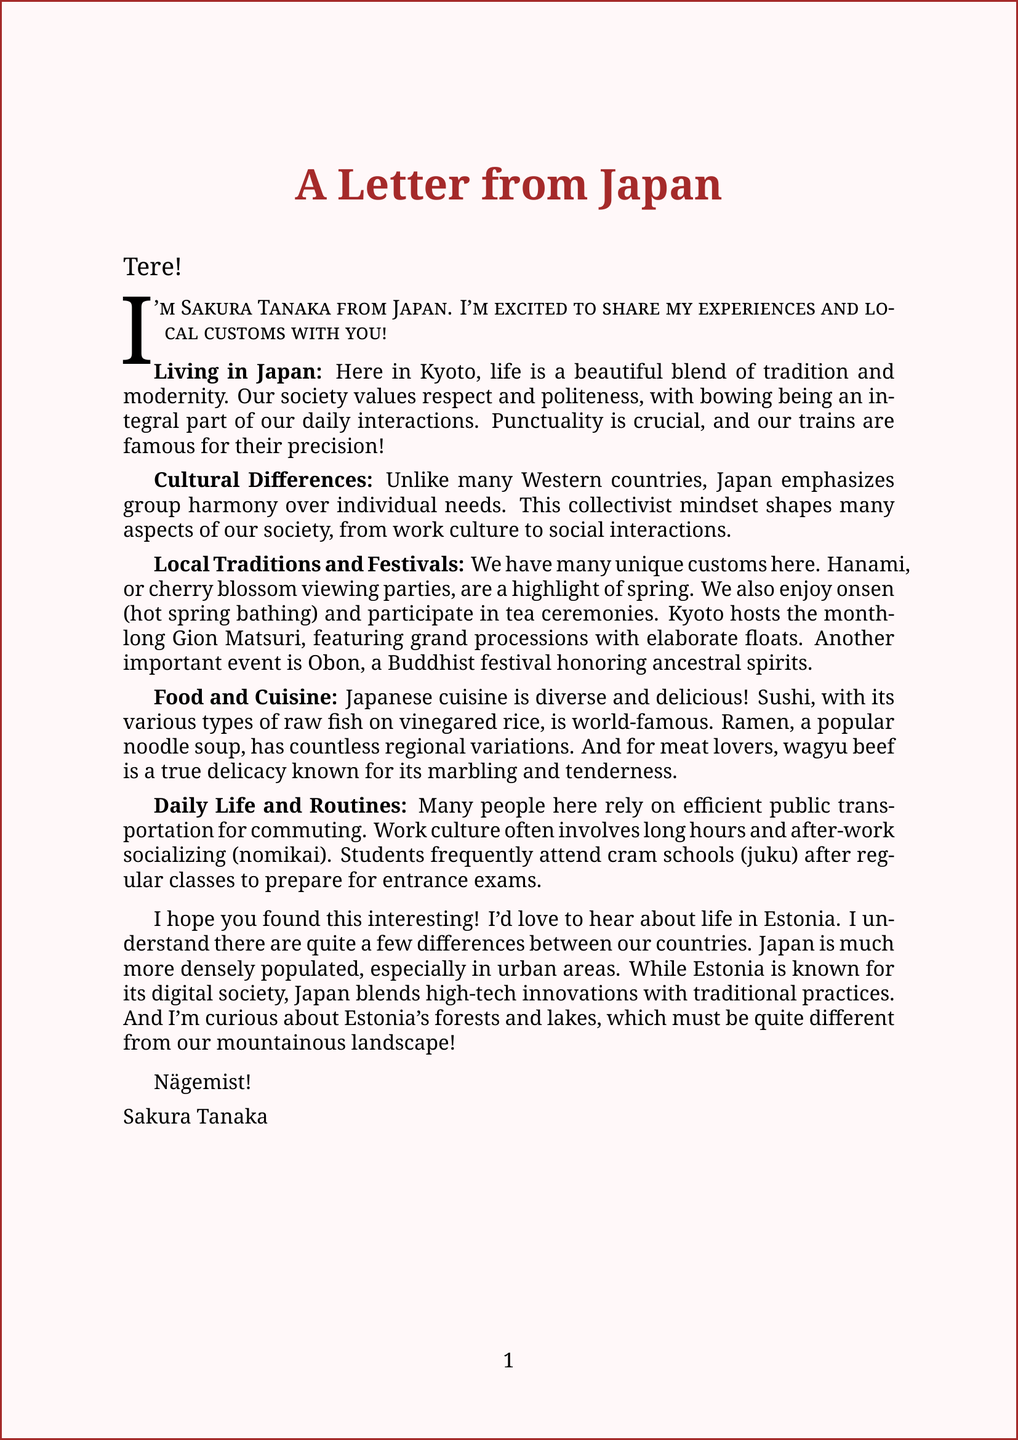what is the name of the pen pal? The letter states that the pen pal's name is Sakura Tanaka.
Answer: Sakura Tanaka which country is the pen pal from? The document mentions that the pen pal is from Japan.
Answer: Japan what is the primary festival mentioned in Kyoto? The letter highlights Gion Matsuri as a month-long festival in Kyoto.
Answer: Gion Matsuri what traditional activity involves cherry blossoms? The document describes Hanami as cherry blossom viewing parties.
Answer: Hanami what is the significance of punctuality in Japan? The letter explains that being on time is crucial and trains are famous for their precision.
Answer: Crucial how does Japanese culture differ from many Western countries? The letter states that Japan emphasizes group harmony over individual needs.
Answer: Group harmony what is a common dish from Japan mentioned in the letter? The letter lists sushi as a popular dish from Japan.
Answer: Sushi what aspect of daily life involves long working hours? The document refers to work culture as involving long working hours.
Answer: Work culture how many years old is the pen pal? The letter mentions that Sakura Tanaka is 22 years old.
Answer: 22 